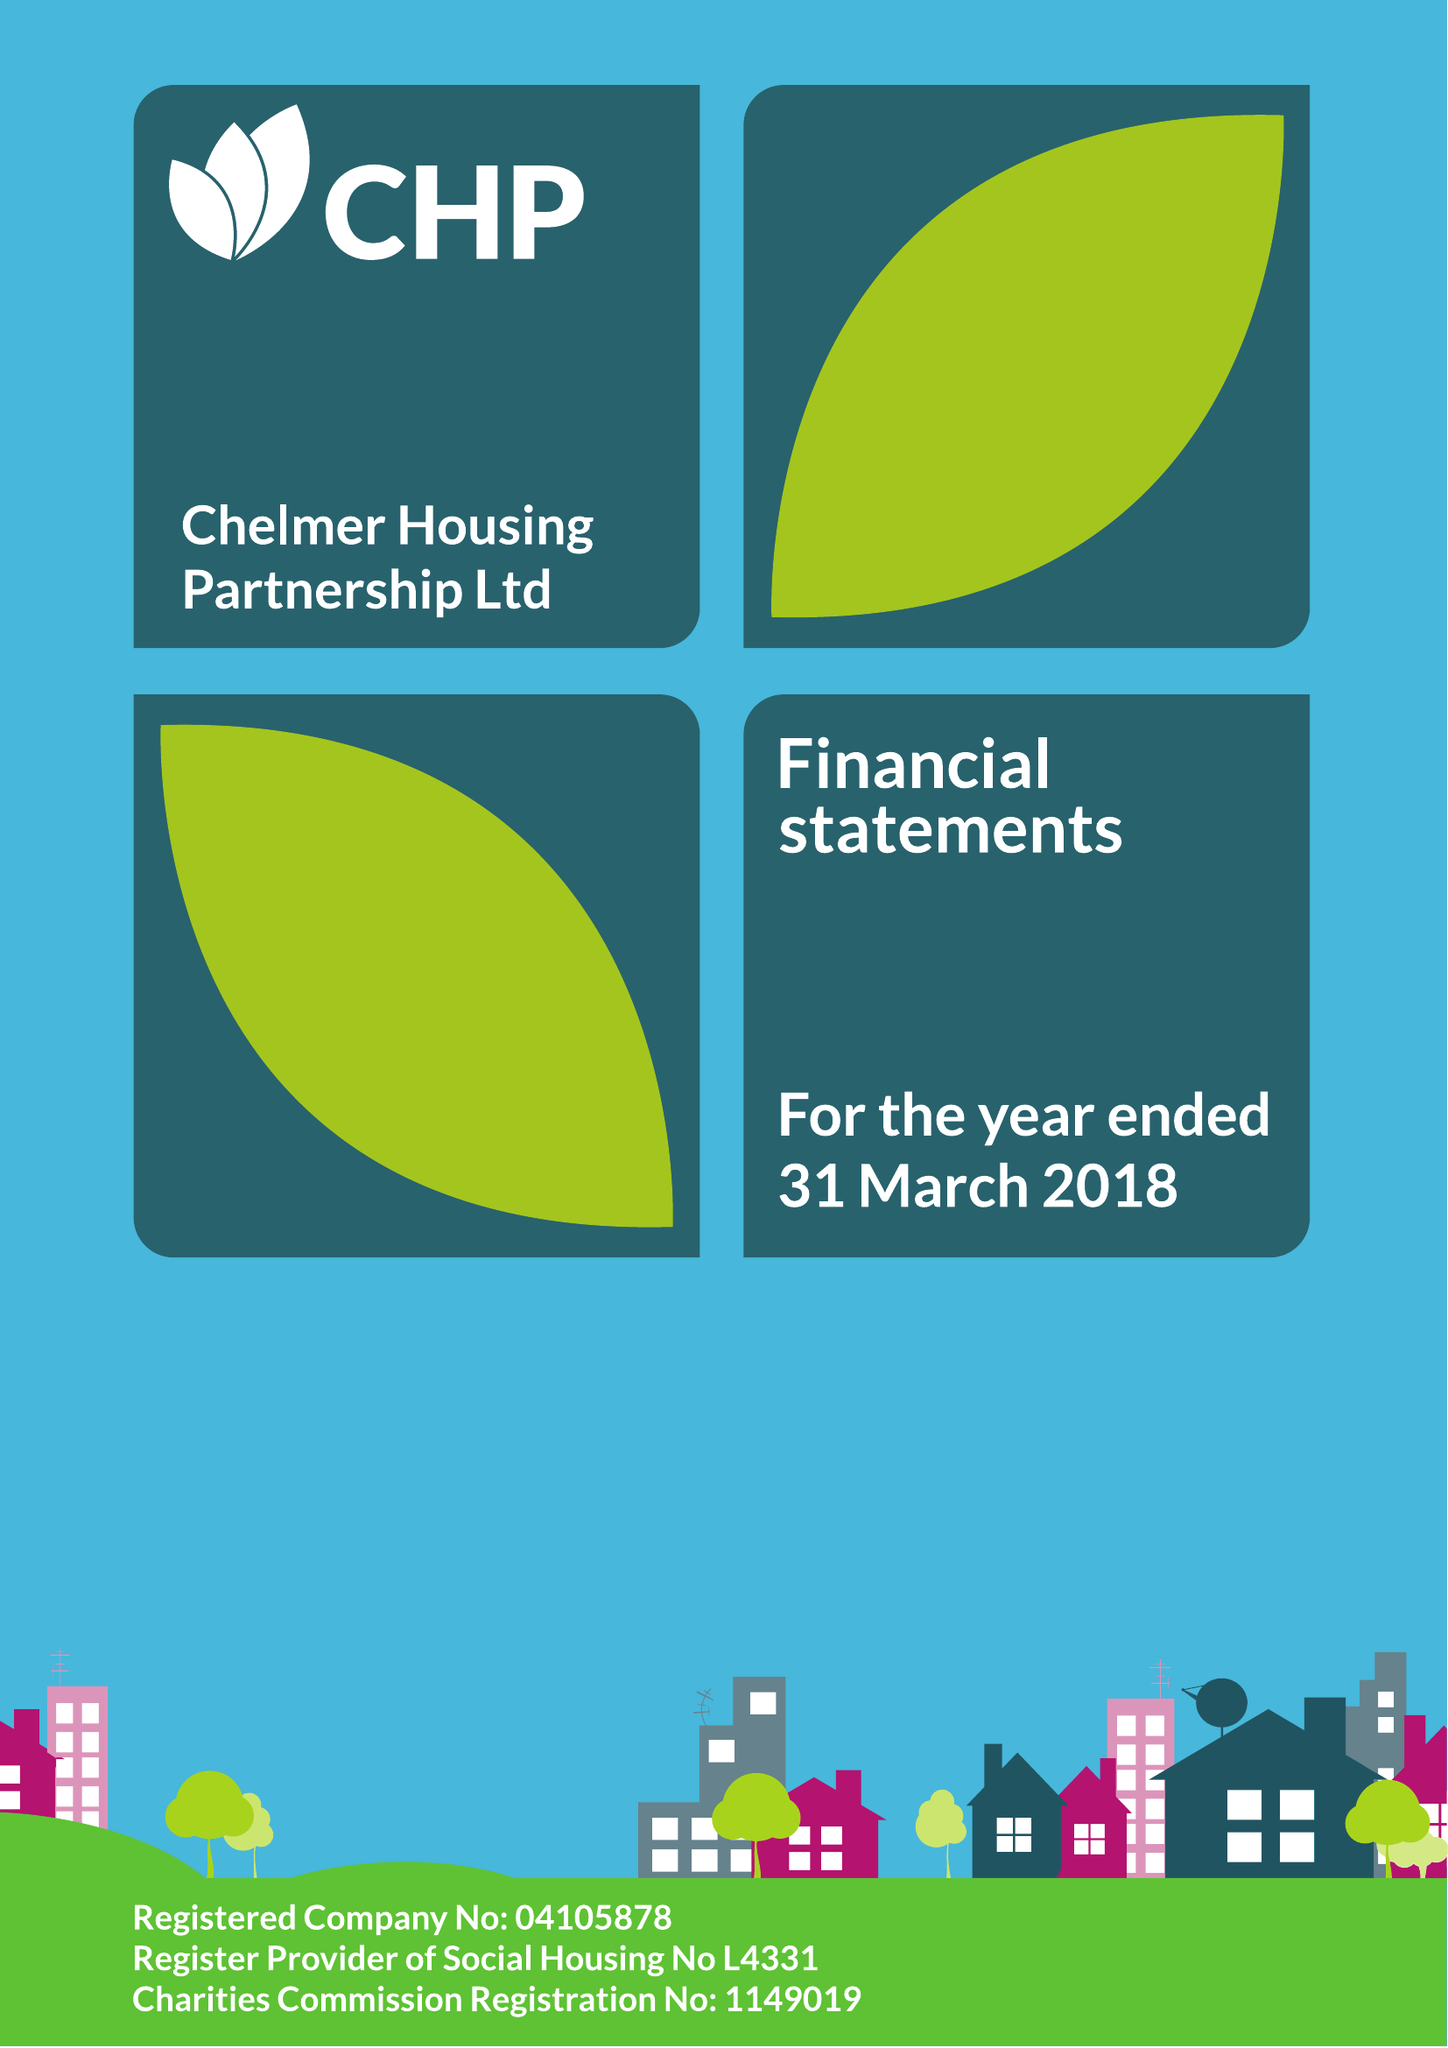What is the value for the address__postcode?
Answer the question using a single word or phrase. CM2 5LB 